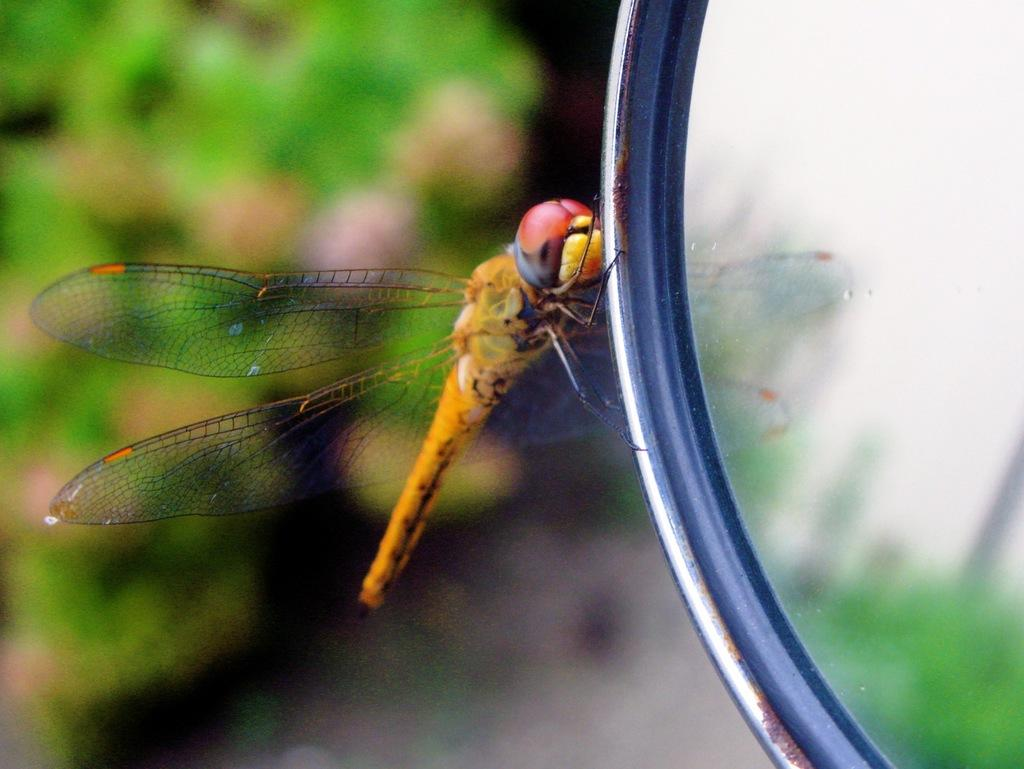What object is located on the right side of the image? There is a mirror on the right side of the image. What is on the mirror in the image? There is a dragonfly on the mirror. Can you describe the background of the image? The background of the image is blurred. What type of camera is being used to take the picture of the rose in the image? There is no camera or rose present in the image; it features a mirror with a dragonfly. 